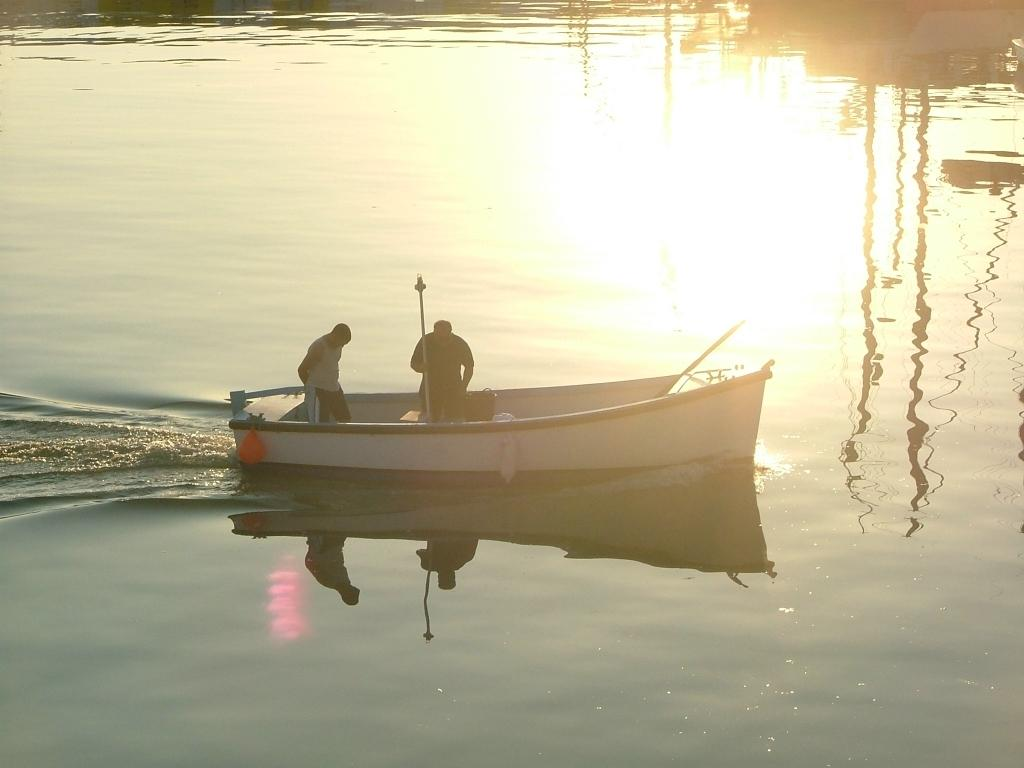What is the main subject of the image? The main subject of the image is a boat. What is the boat's current state in the image? The boat is floating on the water surface. Are there any people in the boat? Yes, there are two people standing in the boat. What color is the downtown area in the image? There is no downtown area present in the image; it features a boat floating on the water surface with two people standing in it. 